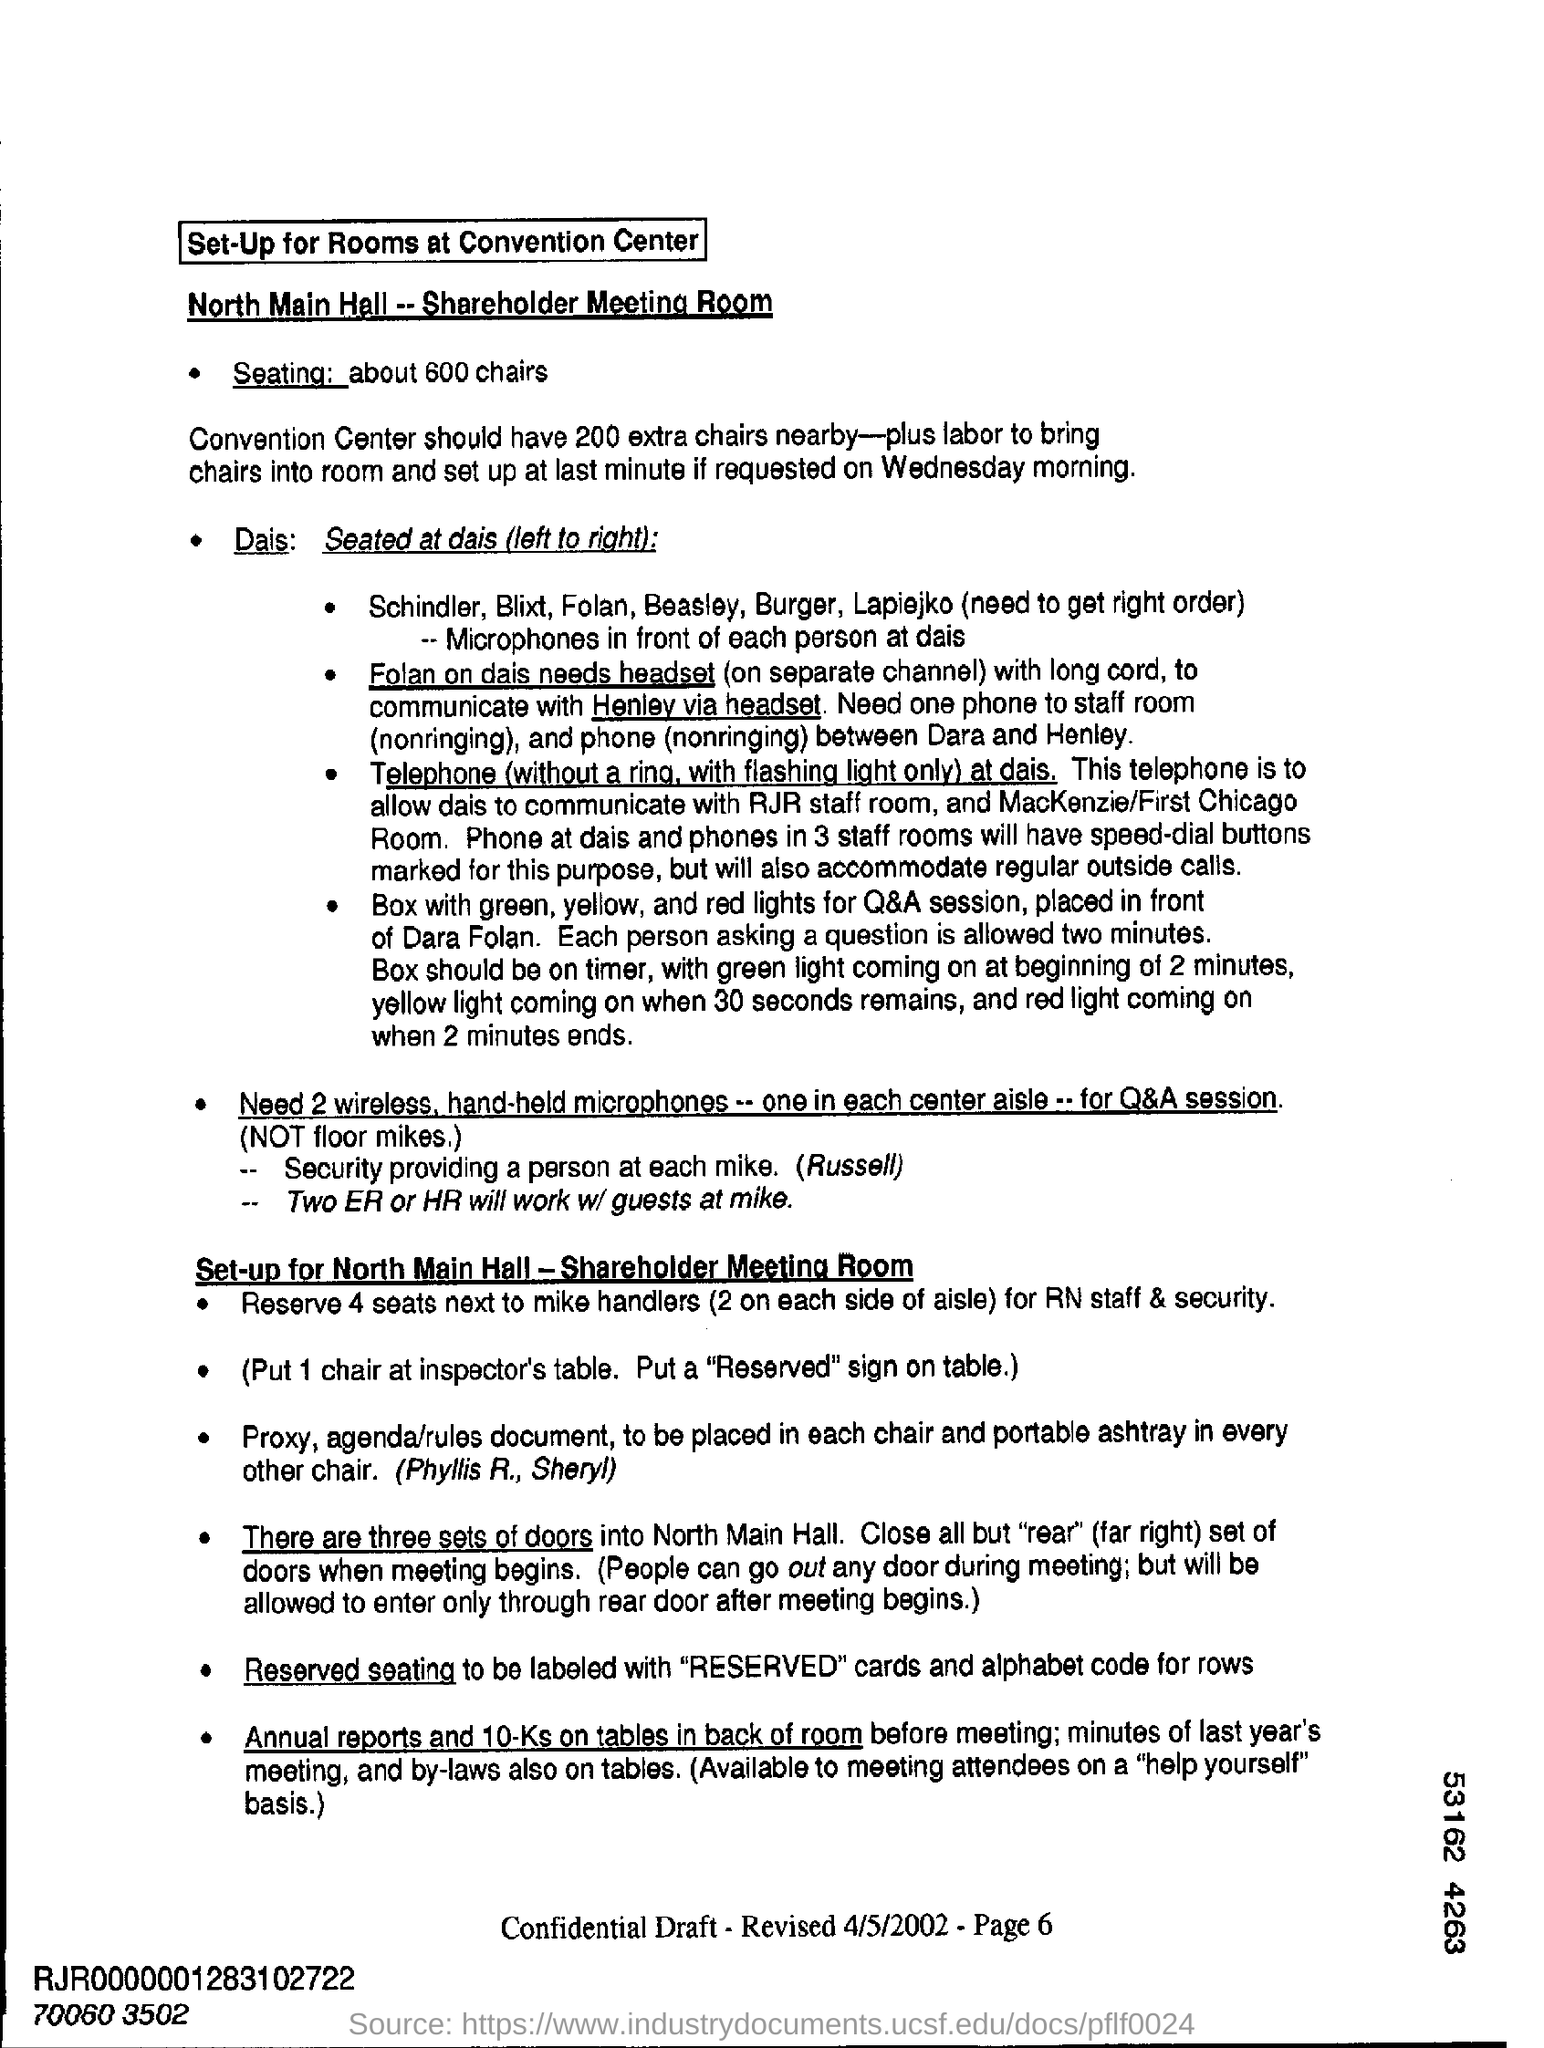How many extra chairs are required at the Convention Center?
Your answer should be very brief. 200. How many chairs are put at the Inspector's table?
Offer a terse response. 1. 